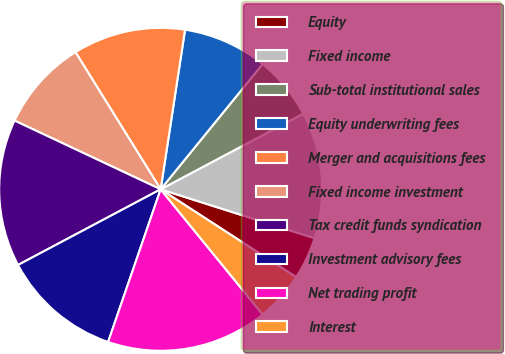Convert chart to OTSL. <chart><loc_0><loc_0><loc_500><loc_500><pie_chart><fcel>Equity<fcel>Fixed income<fcel>Sub-total institutional sales<fcel>Equity underwriting fees<fcel>Merger and acquisitions fees<fcel>Fixed income investment<fcel>Tax credit funds syndication<fcel>Investment advisory fees<fcel>Net trading profit<fcel>Interest<nl><fcel>4.26%<fcel>12.66%<fcel>6.36%<fcel>8.46%<fcel>11.26%<fcel>9.16%<fcel>14.76%<fcel>11.96%<fcel>16.16%<fcel>4.96%<nl></chart> 